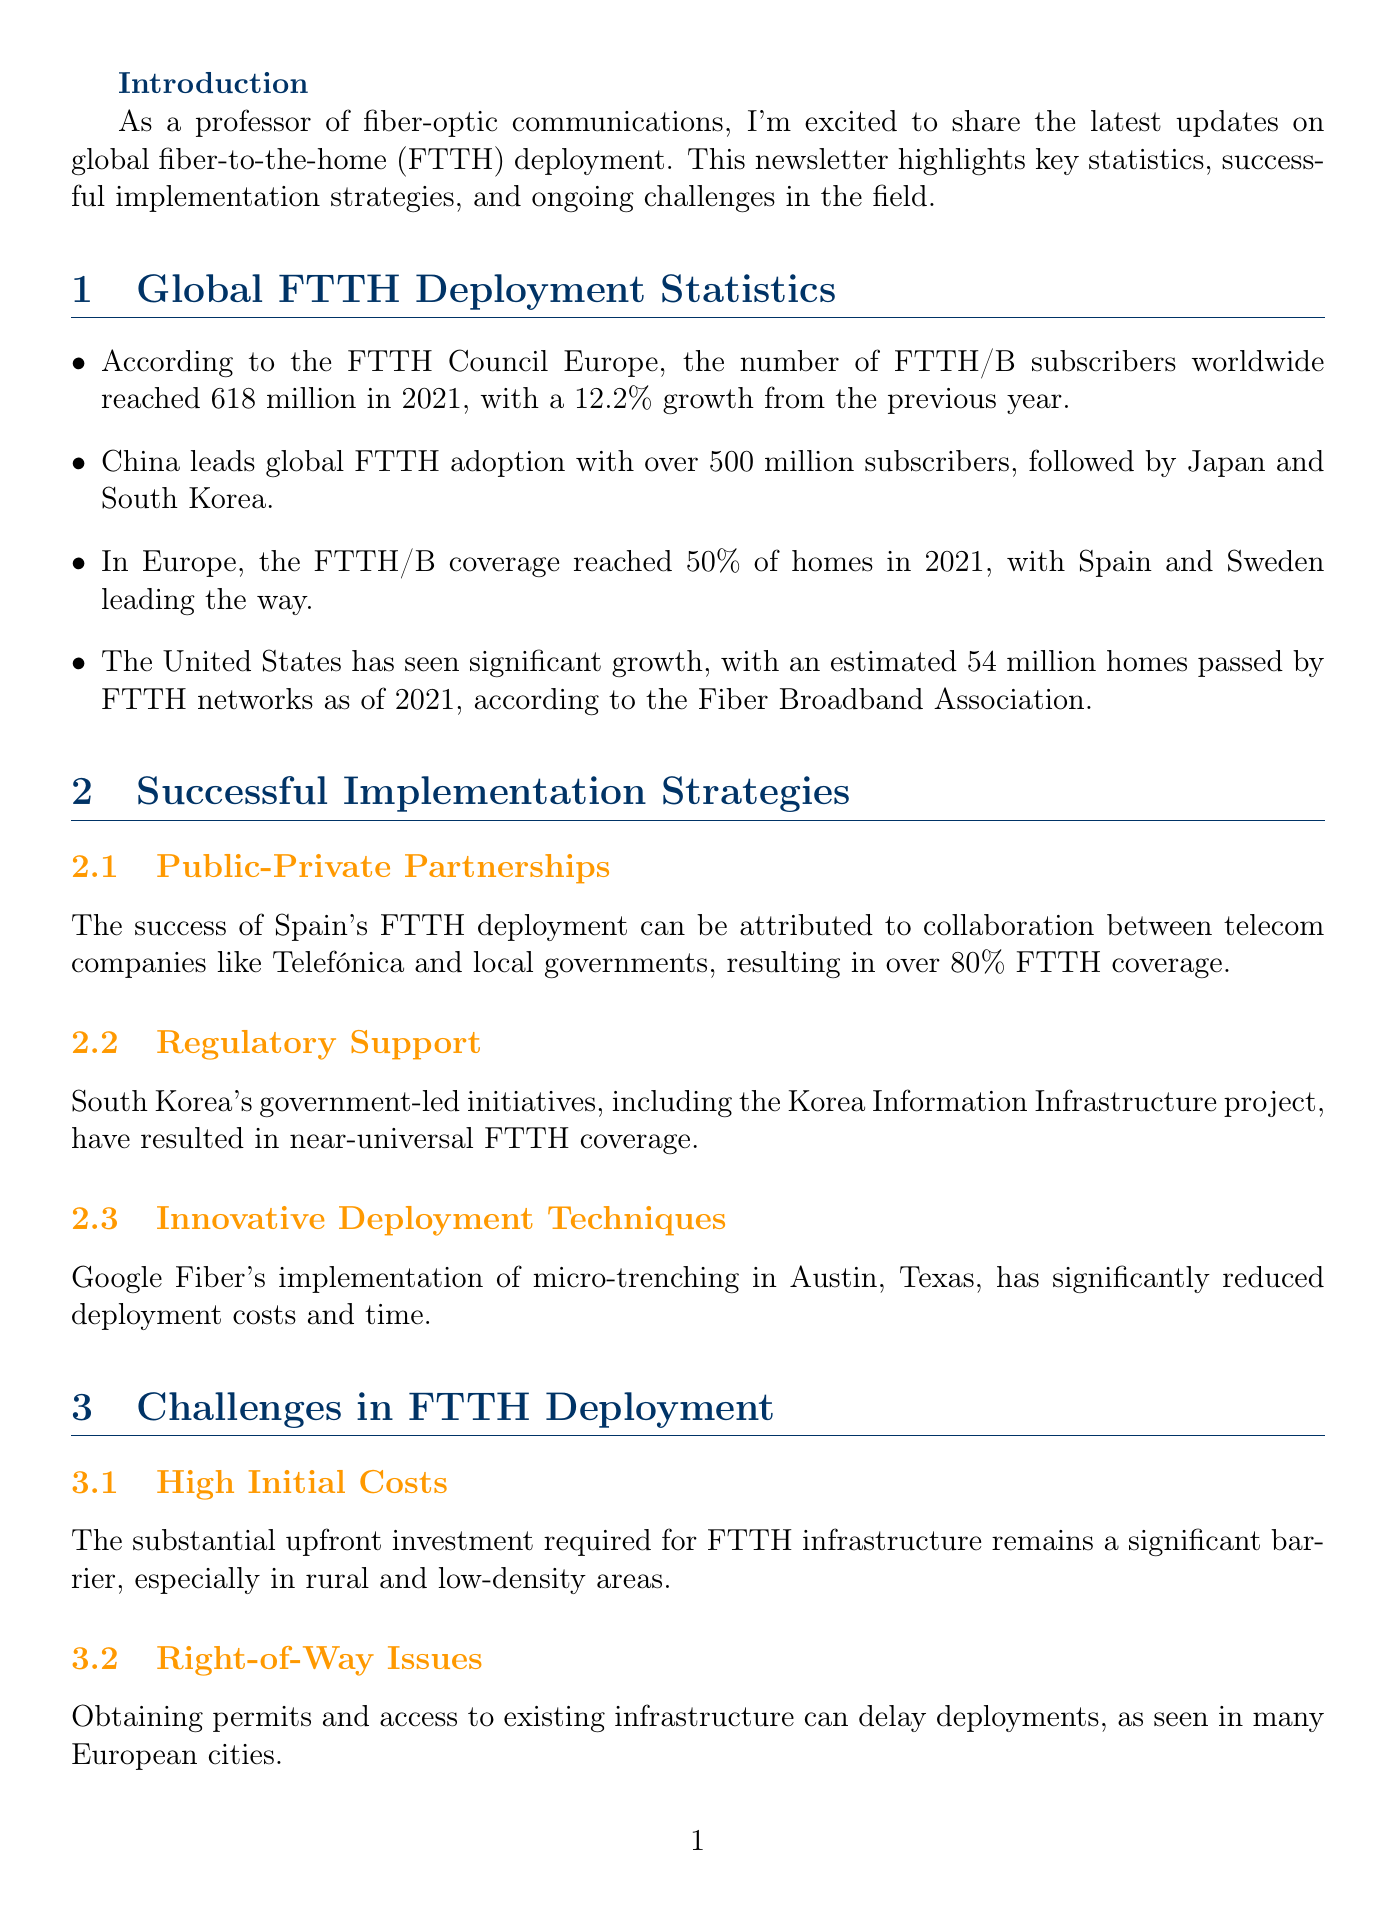what was the number of FTTH/B subscribers worldwide in 2021? The document states that the number of FTTH/B subscribers worldwide reached 618 million in 2021.
Answer: 618 million which country leads global FTTH adoption? The text mentions that China leads global FTTH adoption with over 500 million subscribers.
Answer: China what percentage of homes in Europe had FTTH/B coverage in 2021? The document reports that FTTH/B coverage in Europe reached 50% of homes in 2021.
Answer: 50% what successful strategy helped Spain achieve over 80% FTTH coverage? The document attributes Spain's success to Public-Private Partnerships between telecom companies and local governments.
Answer: Public-Private Partnerships what is a significant challenge in FTTH deployment noted in the document? The document lists several challenges, one being High Initial Costs for FTTH infrastructure.
Answer: High Initial Costs which technology has been adopted by Verizon Fios and AT&T Fiber? The newsletter specifies that XGS-PON technology has been adopted by providers like Verizon Fios and AT&T Fiber.
Answer: XGS-PON technology what innovative technique did Google Fiber implement to reduce costs? According to the document, Google Fiber's implementation of micro-trenching has significantly reduced deployment costs.
Answer: micro-trenching who is the author of the newsletter? The document reveals that Dr. Sarah Chen is the author of the newsletter.
Answer: Dr. Sarah Chen 